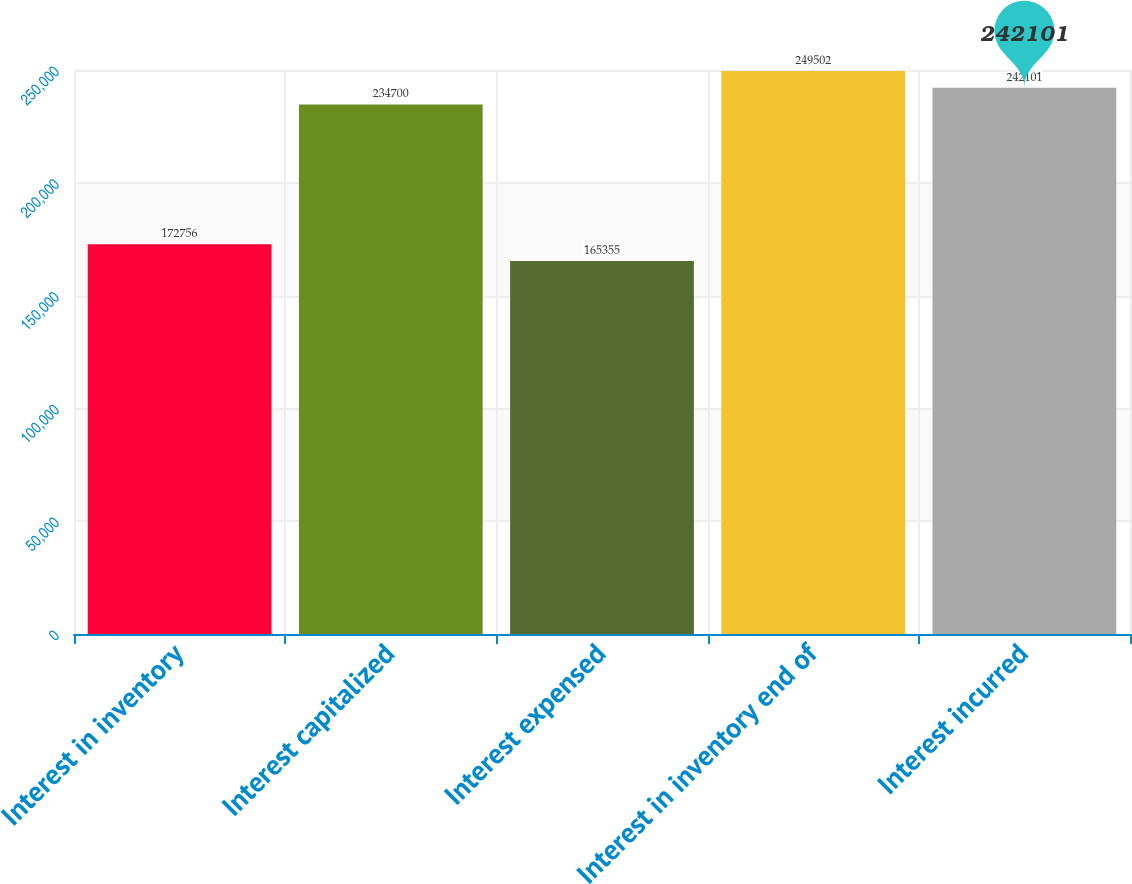Convert chart. <chart><loc_0><loc_0><loc_500><loc_500><bar_chart><fcel>Interest in inventory<fcel>Interest capitalized<fcel>Interest expensed<fcel>Interest in inventory end of<fcel>Interest incurred<nl><fcel>172756<fcel>234700<fcel>165355<fcel>249502<fcel>242101<nl></chart> 